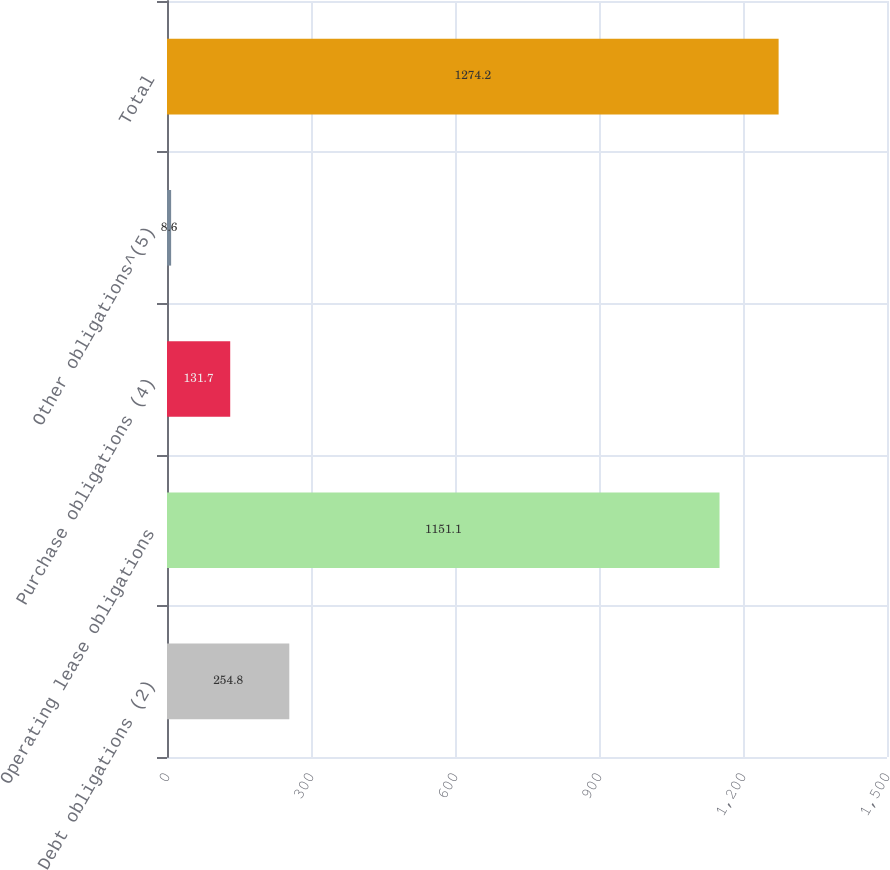Convert chart. <chart><loc_0><loc_0><loc_500><loc_500><bar_chart><fcel>Debt obligations (2)<fcel>Operating lease obligations<fcel>Purchase obligations (4)<fcel>Other obligations^(5)<fcel>Total<nl><fcel>254.8<fcel>1151.1<fcel>131.7<fcel>8.6<fcel>1274.2<nl></chart> 